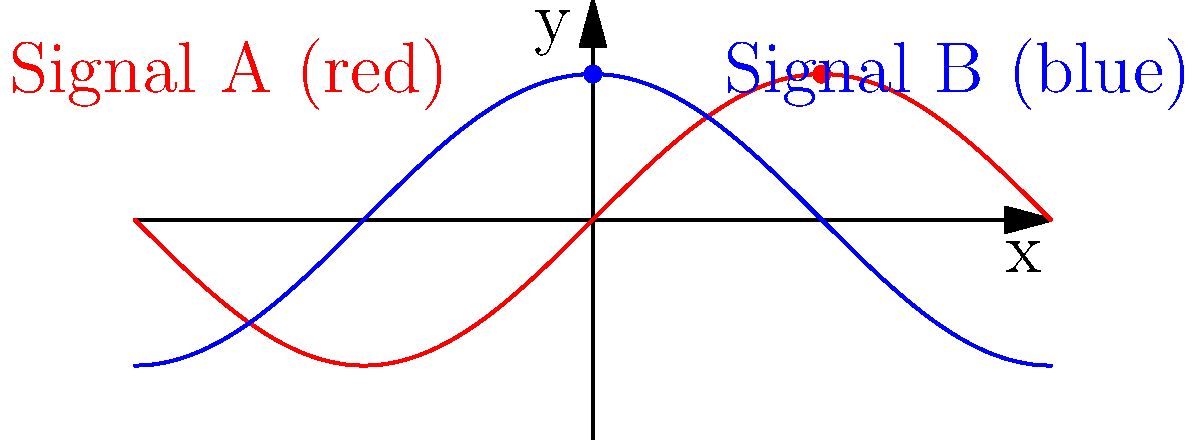In the land of "Broadcastopia," two rival networks are battling it out in the airwaves. Their signal patterns are represented by the red and blue curves in the graph. At what point along the x-axis do these signals reach their maximum constructive interference, creating a potential ratings supernova? Let's break this down with the irreverence of a seasoned broadcaster:

1. The red curve (Signal A) represents $f(x) = \sin(x)$, while the blue curve (Signal B) represents $g(x) = \cos(x)$.

2. Constructive interference occurs when both signals are at their peak simultaneously.

3. $\sin(x)$ reaches its maximum value of 1 at $x = \frac{\pi}{2}$ (or 90 degrees for the old-school folks).

4. $\cos(x)$ reaches its maximum value of 1 at $x = 0$ (or 0 degrees, as boring as a rerun).

5. To find where both signals are at their peak, we need to solve:
   $$\sin(x) = 1 \text{ and } \cos(x) = 1$$

6. This occurs at $x = \frac{\pi}{2} + 2\pi n$, where $n$ is any integer.

7. The first (and smallest positive) solution is at $x = \frac{\pi}{2}$.

So, at $x = \frac{\pi}{2}$, our rival networks inadvertently create a ratings bonanza that would make even the most jaded network exec's heart skip a beat!
Answer: $\frac{\pi}{2}$ 